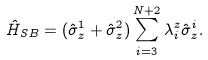<formula> <loc_0><loc_0><loc_500><loc_500>\hat { H } _ { S B } = ( \hat { \sigma } _ { z } ^ { 1 } + \hat { \sigma } _ { z } ^ { 2 } ) \sum _ { i = 3 } ^ { N + 2 } \lambda _ { i } ^ { z } \hat { \sigma } _ { z } ^ { i } .</formula> 